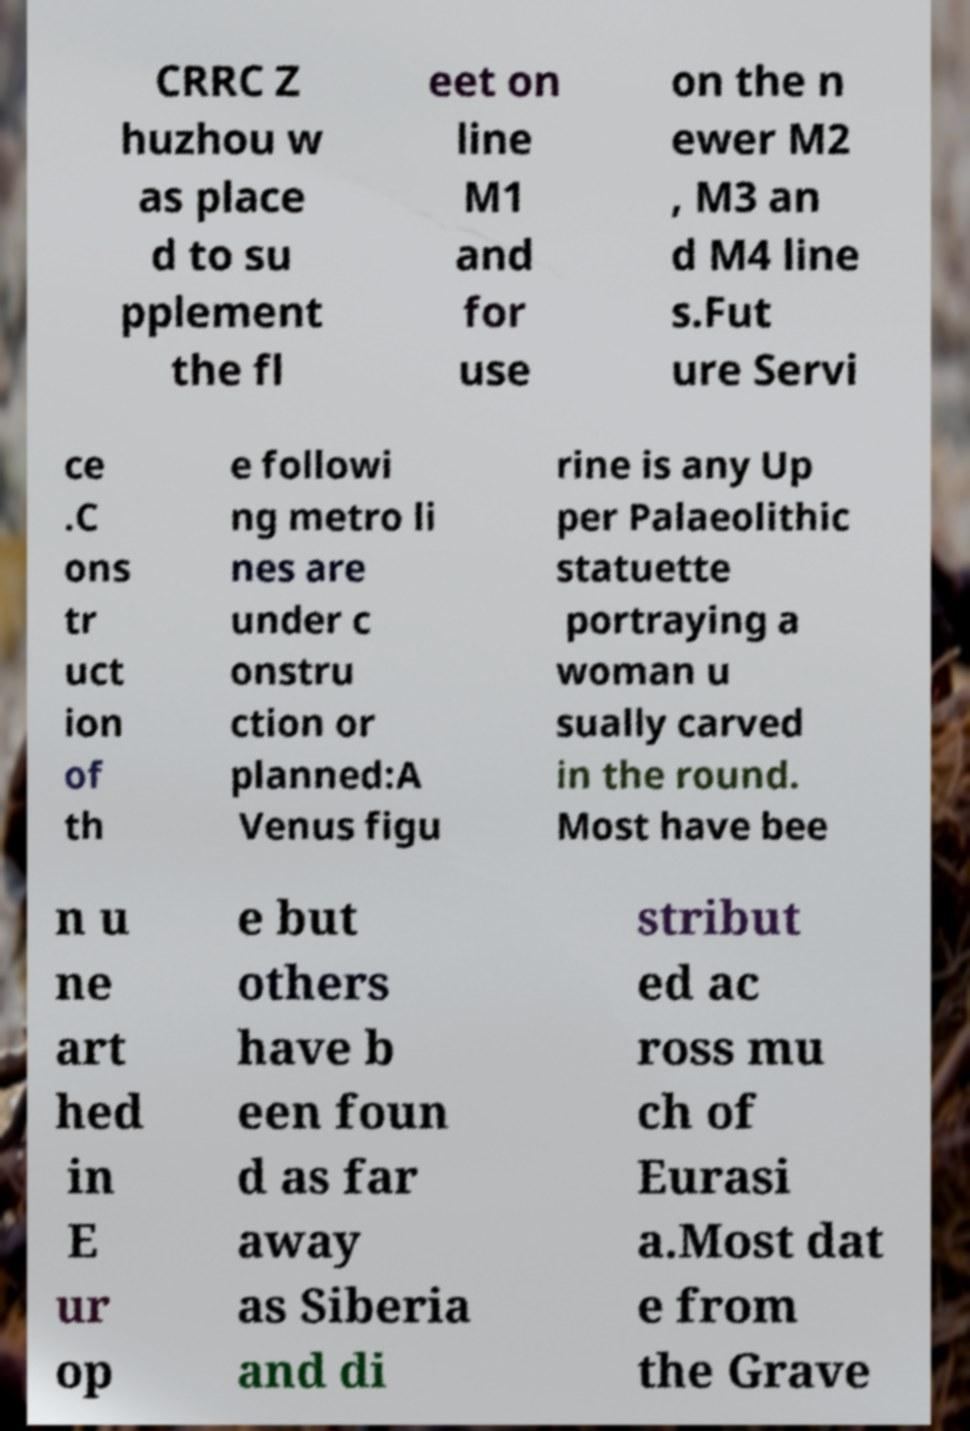I need the written content from this picture converted into text. Can you do that? CRRC Z huzhou w as place d to su pplement the fl eet on line M1 and for use on the n ewer M2 , M3 an d M4 line s.Fut ure Servi ce .C ons tr uct ion of th e followi ng metro li nes are under c onstru ction or planned:A Venus figu rine is any Up per Palaeolithic statuette portraying a woman u sually carved in the round. Most have bee n u ne art hed in E ur op e but others have b een foun d as far away as Siberia and di stribut ed ac ross mu ch of Eurasi a.Most dat e from the Grave 